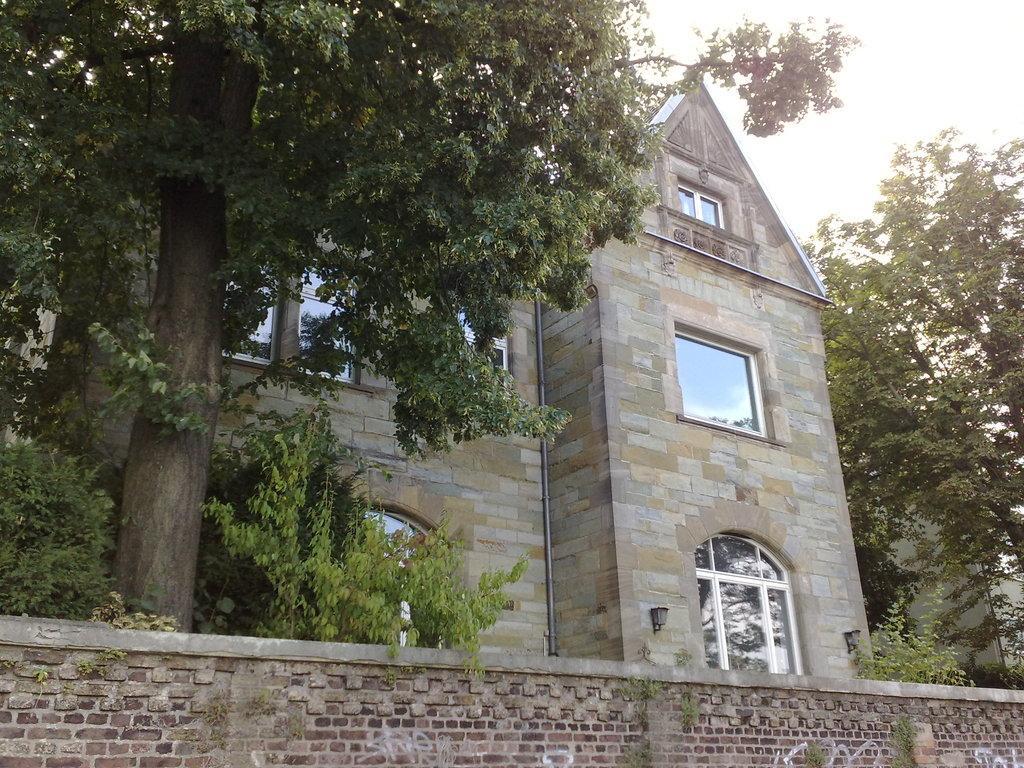Could you give a brief overview of what you see in this image? There is a wall at the bottom of this image. We can see trees and a building in the middle of this image. The sky is in the background. 